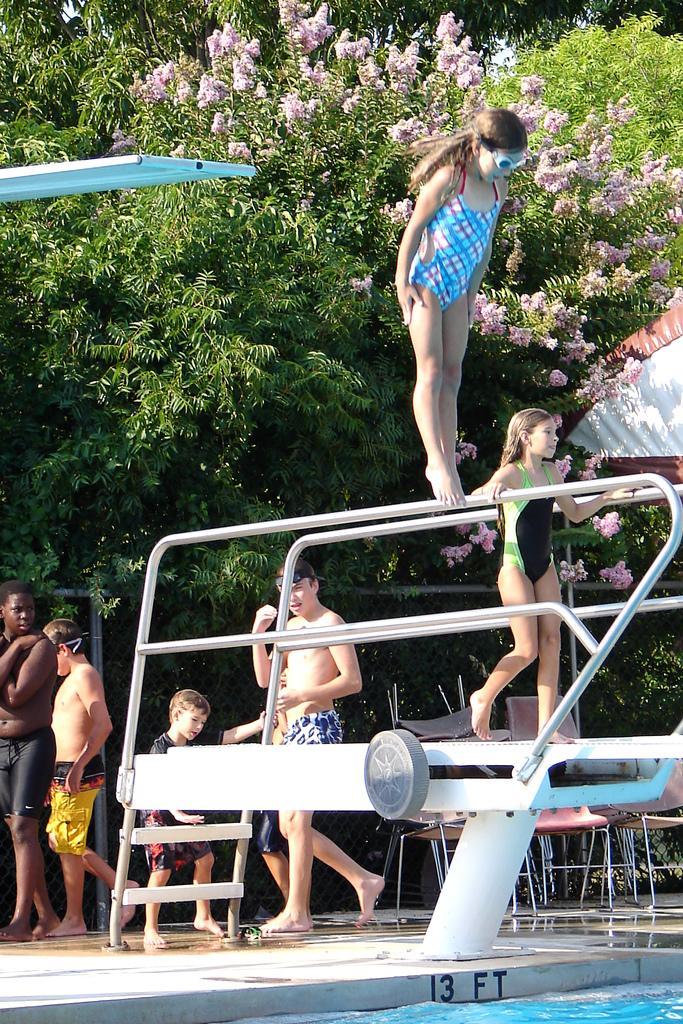In one or two sentences, can you explain what this image depicts? In this picture we can see water at the bottom, there are some people here, we can see trees and flowers in the background. 